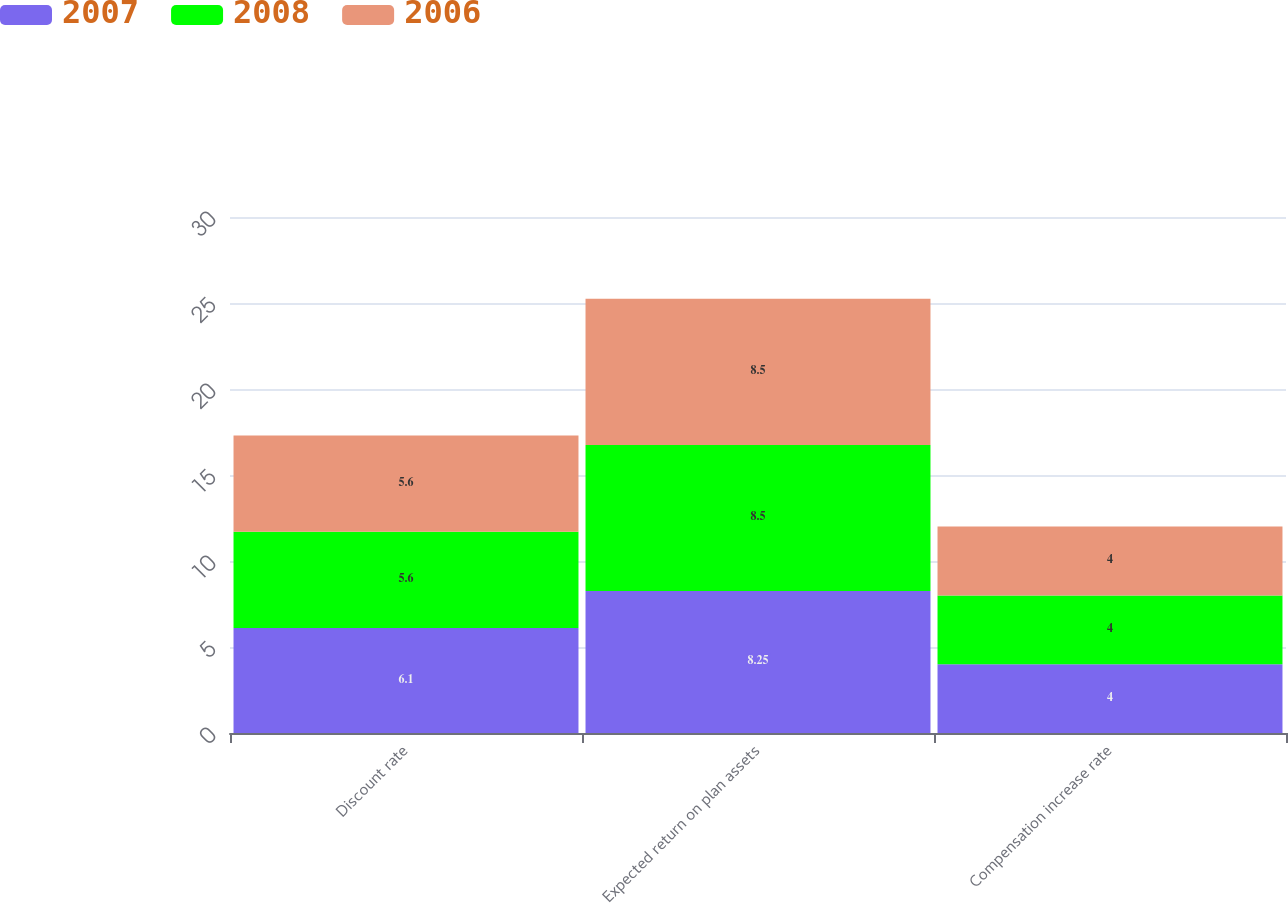Convert chart. <chart><loc_0><loc_0><loc_500><loc_500><stacked_bar_chart><ecel><fcel>Discount rate<fcel>Expected return on plan assets<fcel>Compensation increase rate<nl><fcel>2007<fcel>6.1<fcel>8.25<fcel>4<nl><fcel>2008<fcel>5.6<fcel>8.5<fcel>4<nl><fcel>2006<fcel>5.6<fcel>8.5<fcel>4<nl></chart> 